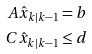<formula> <loc_0><loc_0><loc_500><loc_500>A \hat { x } _ { k | k - 1 } = b \\ C \hat { x } _ { k | k - 1 } \leq d</formula> 